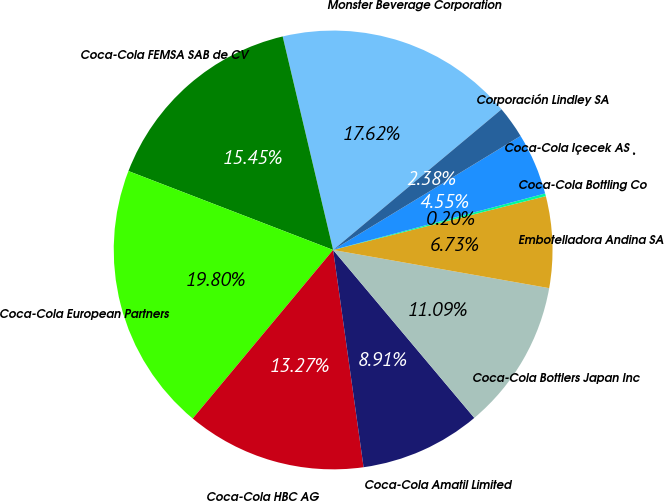Convert chart. <chart><loc_0><loc_0><loc_500><loc_500><pie_chart><fcel>Monster Beverage Corporation<fcel>Coca-Cola FEMSA SAB de CV<fcel>Coca-Cola European Partners<fcel>Coca-Cola HBC AG<fcel>Coca-Cola Amatil Limited<fcel>Coca-Cola Bottlers Japan Inc<fcel>Embotelladora Andina SA<fcel>Coca-Cola Bottling Co<fcel>Coca-Cola Içecek AS ¸<fcel>Corporación Lindley SA<nl><fcel>17.62%<fcel>15.45%<fcel>19.8%<fcel>13.27%<fcel>8.91%<fcel>11.09%<fcel>6.73%<fcel>0.2%<fcel>4.55%<fcel>2.38%<nl></chart> 